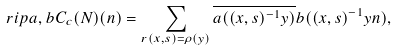<formula> <loc_0><loc_0><loc_500><loc_500>\ r i p { a , b } { C _ { c } ( N ) } ( n ) = \sum _ { r ( x , s ) = \rho ( y ) } \overline { a ( ( x , s ) ^ { - 1 } y ) } b ( ( x , s ) ^ { - 1 } y n ) ,</formula> 